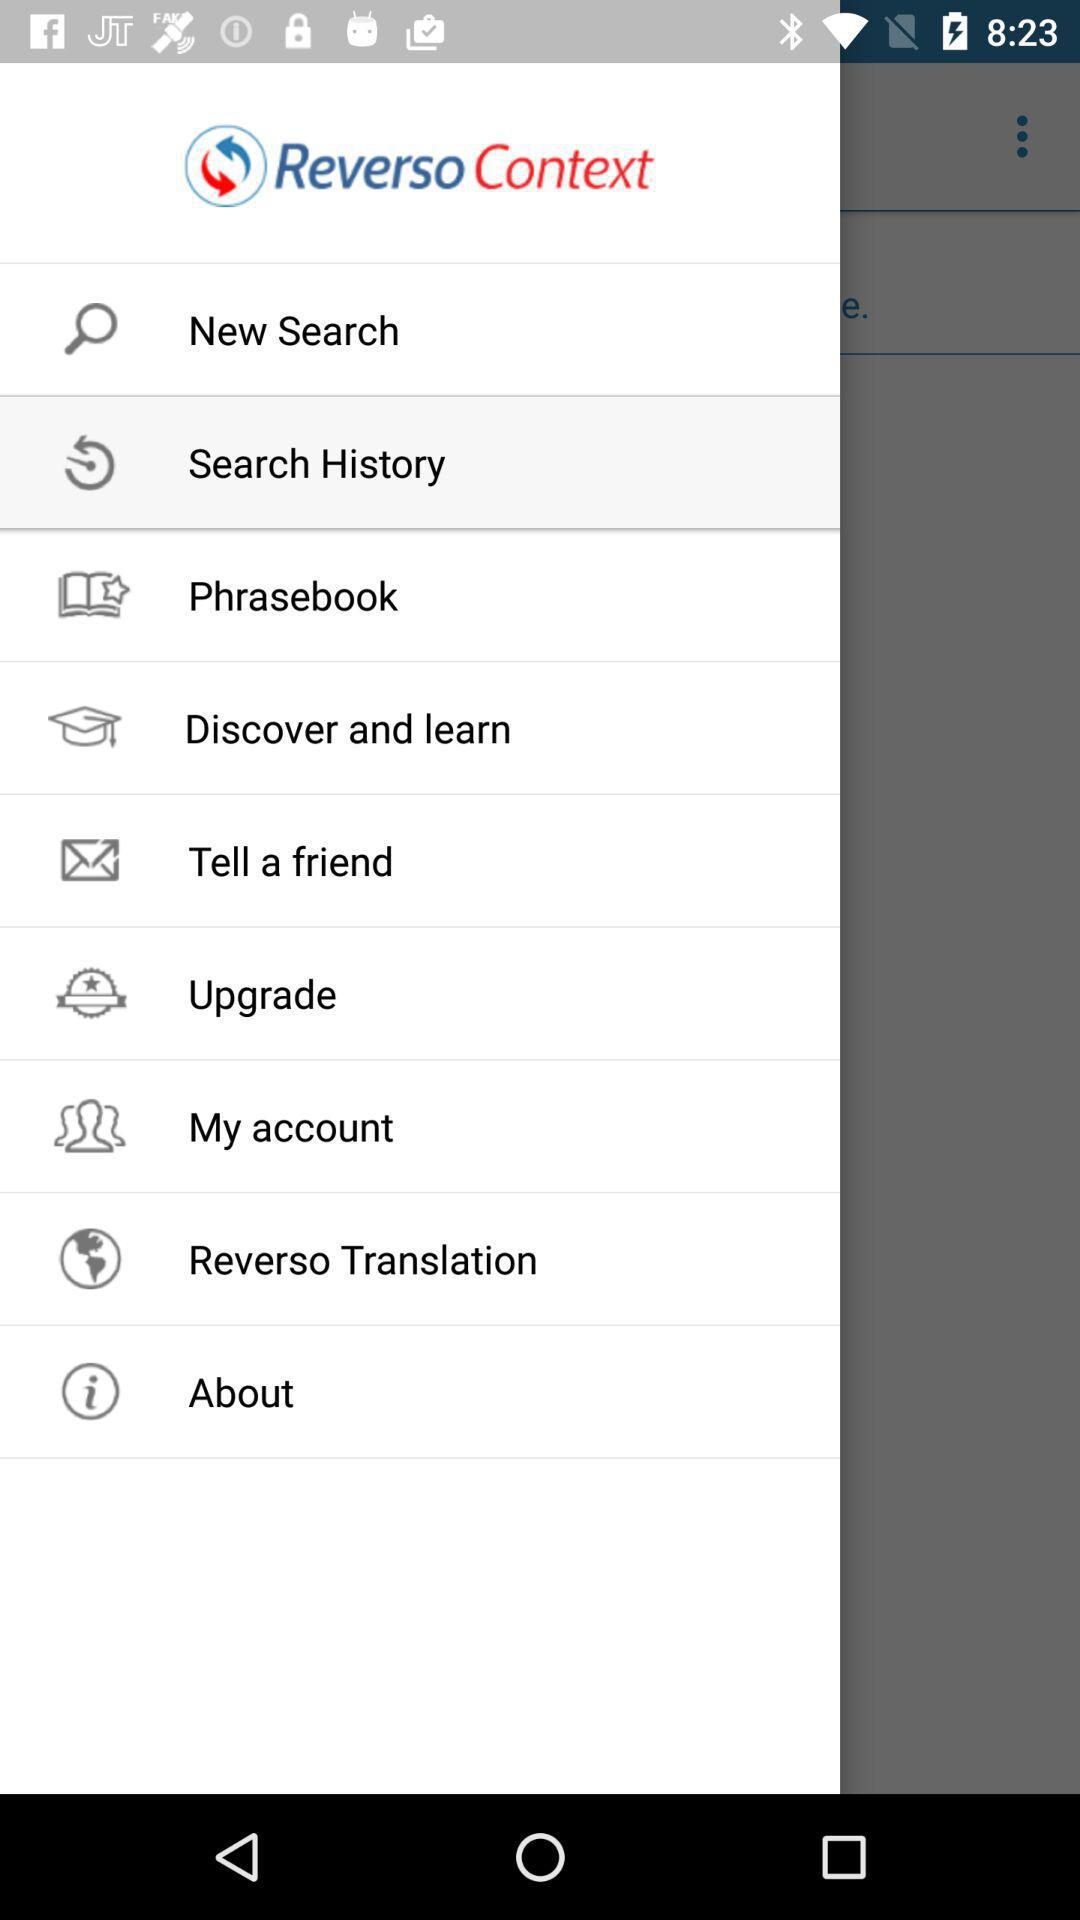What is the name of the application? The application name is "Reverso Context". 